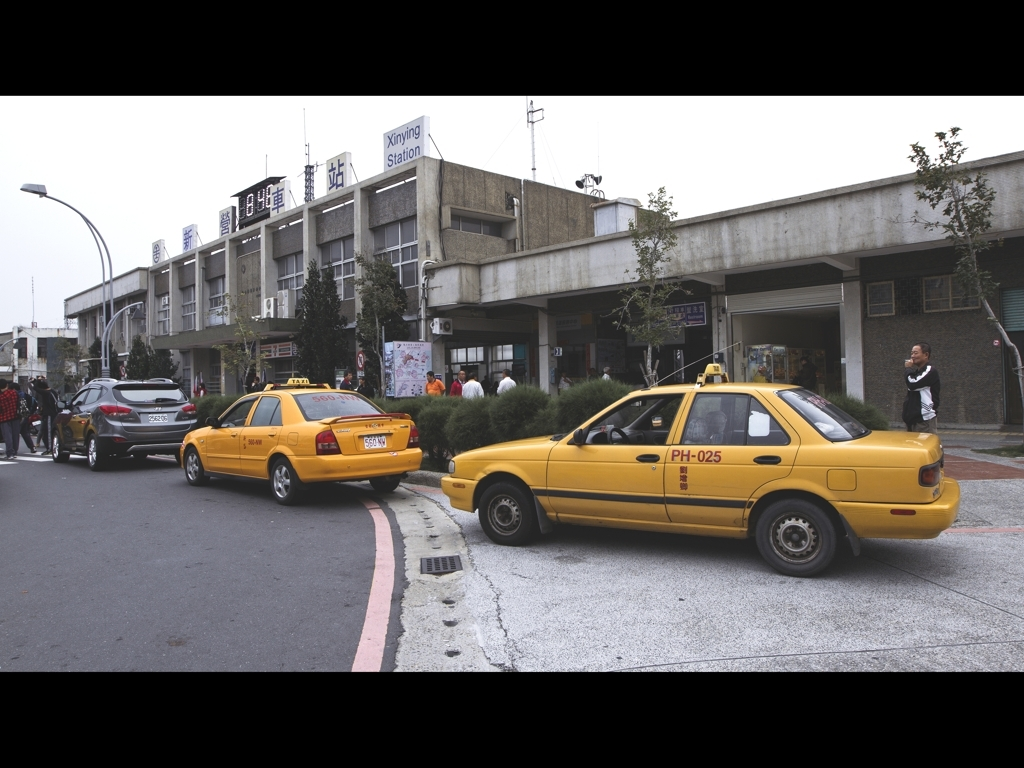Are there any quality issues with this image? The image appears to have a slightly faded color profile, which could be due to overcast weather or the settings of the camera. Additionally, there is some noticeable noise in the darker areas, suggesting a high ISO setting or a low-end camera sensor. Furthermore, the overall composition could be improved for better visual appeal. 